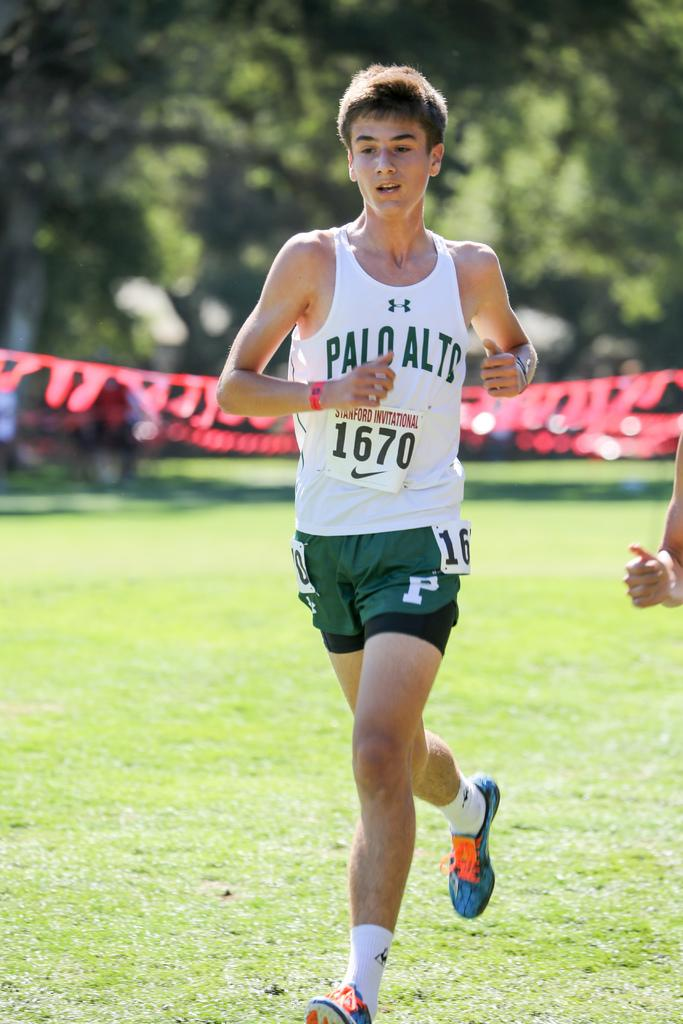<image>
Summarize the visual content of the image. A young man is running and has the word invitational on his jersey. 